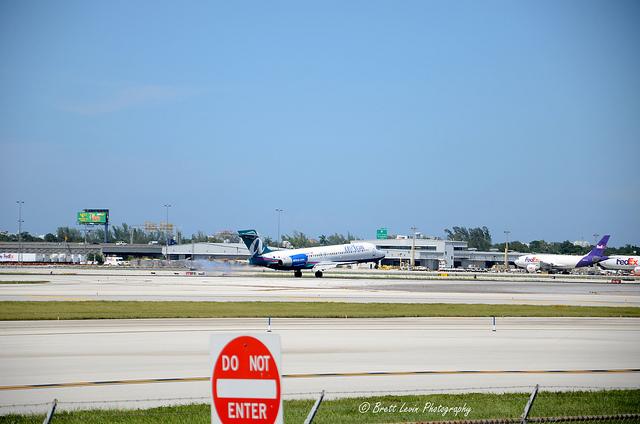Is the plane landing or taking off?
Answer briefly. Taking off. How many FedEx planes are there?
Quick response, please. 2. Where is this location?
Concise answer only. Airport. 